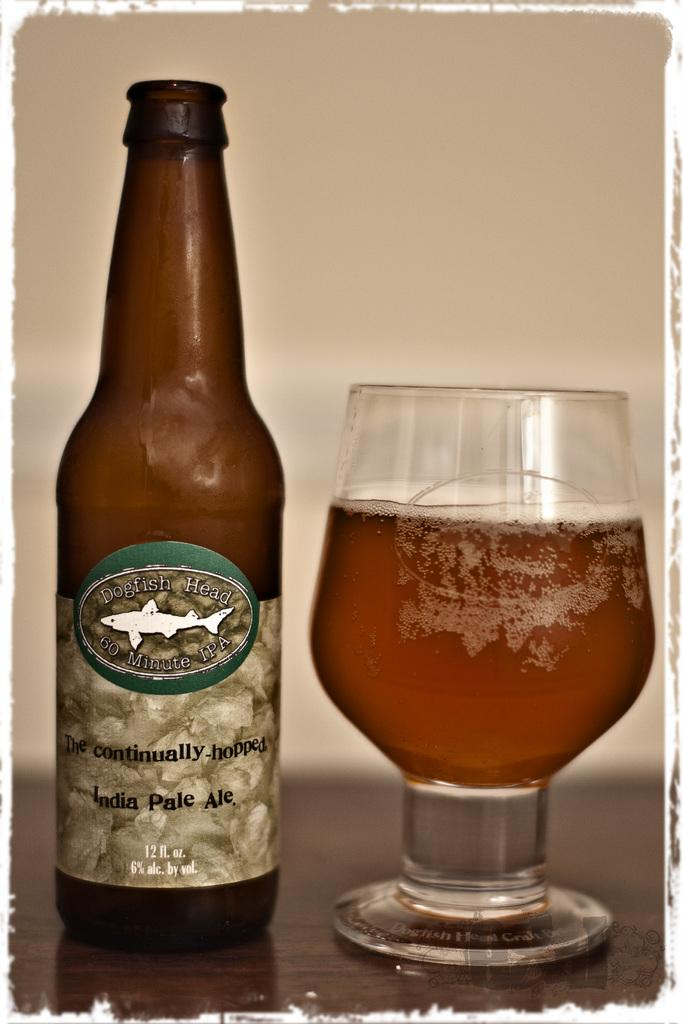<image>
Give a short and clear explanation of the subsequent image. A glass of beer sits next to a bottle of IPA. 